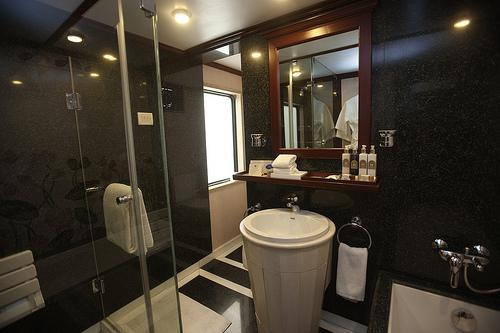Question: what is to the right of the sink?
Choices:
A. A toilet.
B. A sink.
C. Towel rack.
D. A mirror.
Answer with the letter. Answer: C Question: how many towels are in this photo?
Choices:
A. 3.
B. 0.
C. 5.
D. 4.
Answer with the letter. Answer: A Question: who is standing next to the sink?
Choices:
A. A tall man.
B. A short little boy.
C. No one.
D. A cat.
Answer with the letter. Answer: C 